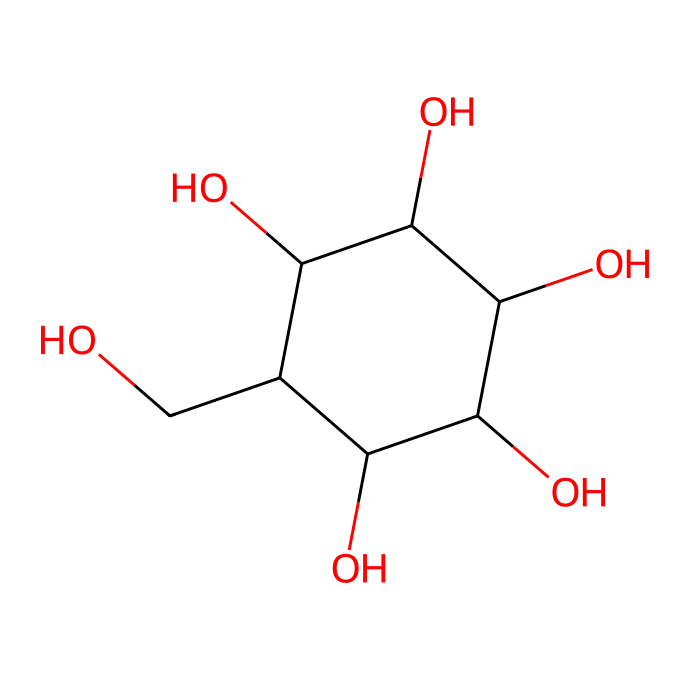What is the molecular formula of glucose? By analyzing the provided SMILES representation, we can count the atoms of each element present. Glucose contains 6 carbon atoms, 12 hydrogen atoms, and 6 oxygen atoms, leading to a molecular formula of C6H12O6.
Answer: C6H12O6 How many hydroxyl (OH) groups are present in glucose? In the chemical structure indicated by the SMILES, we identify the hydroxyl groups (OH). Glucose has 5 hydroxyl groups, as indicated by the presence of 5 hydroxyl moieties in the structure.
Answer: 5 What type of carbohydrate is glucose classified as? Glucose is classified as a monosaccharide because it is a simple sugar composed of a single carbohydrate unit with no other sugars linked together.
Answer: monosaccharide What is the degree of saturation in glucose? To determine the degree of saturation, we can assess the number of rings and double bonds present in the structure. Glucose has no double bonds and contains a single ring structure, thus its degree of saturation is considered to be fully saturated.
Answer: saturated What characteristic of glucose enables it to be a natural sweetener? The presence of hydroxyl groups (OH) contributes to its interaction with taste receptors on the tongue, which is a key characteristic that allows glucose to taste sweet.
Answer: hydroxyl groups What is the total number of carbon atoms in glucose? By directly counting the number of carbon atoms represented in the SMILES notation, we find that there are 6 carbon atoms in the glucose structure.
Answer: 6 Is glucose an example of an electrolyte? Glucose does not dissociate into ions when dissolved in water, thus it is classified as a non-electrolyte.
Answer: non-electrolyte 